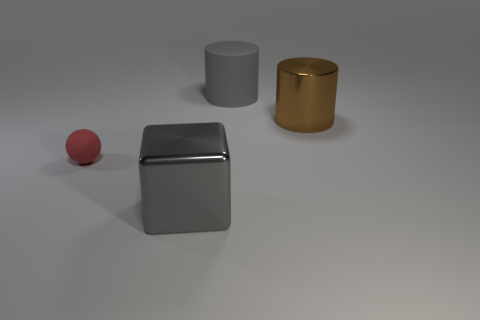Add 4 yellow objects. How many objects exist? 8 Subtract all spheres. How many objects are left? 3 Subtract 2 cylinders. How many cylinders are left? 0 Subtract all blue blocks. Subtract all brown balls. How many blocks are left? 1 Subtract all blue blocks. How many brown cylinders are left? 1 Subtract all large cyan matte cubes. Subtract all big gray matte cylinders. How many objects are left? 3 Add 1 cylinders. How many cylinders are left? 3 Add 4 big objects. How many big objects exist? 7 Subtract 0 brown spheres. How many objects are left? 4 